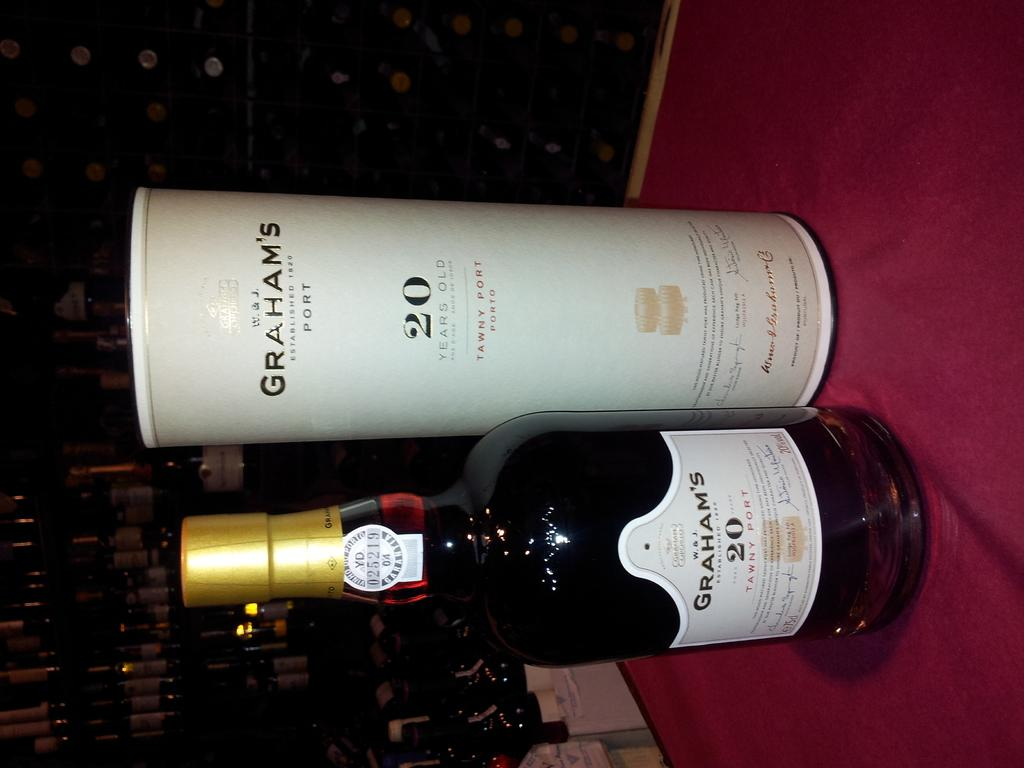<image>
Present a compact description of the photo's key features. A bottle of Graham's 20 next to the cannister it came in. 